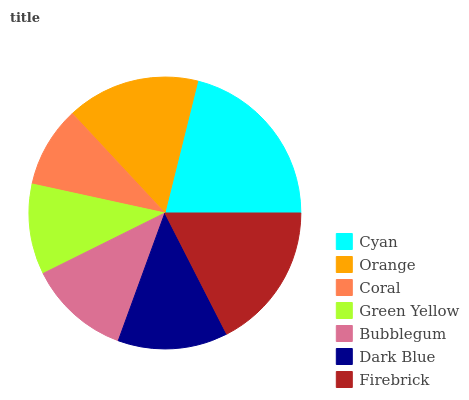Is Coral the minimum?
Answer yes or no. Yes. Is Cyan the maximum?
Answer yes or no. Yes. Is Orange the minimum?
Answer yes or no. No. Is Orange the maximum?
Answer yes or no. No. Is Cyan greater than Orange?
Answer yes or no. Yes. Is Orange less than Cyan?
Answer yes or no. Yes. Is Orange greater than Cyan?
Answer yes or no. No. Is Cyan less than Orange?
Answer yes or no. No. Is Dark Blue the high median?
Answer yes or no. Yes. Is Dark Blue the low median?
Answer yes or no. Yes. Is Bubblegum the high median?
Answer yes or no. No. Is Bubblegum the low median?
Answer yes or no. No. 